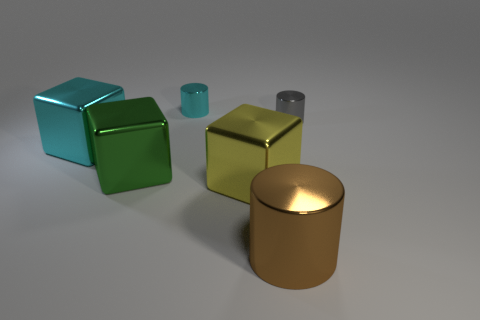Does the brown cylinder have the same size as the cube that is left of the green cube?
Offer a terse response. Yes. There is a cyan object that is in front of the cyan object behind the tiny cylinder that is right of the big brown metallic cylinder; how big is it?
Your answer should be very brief. Large. What size is the green object that is right of the large cyan thing?
Make the answer very short. Large. The gray object that is the same material as the big brown object is what shape?
Your answer should be compact. Cylinder. How many other things are made of the same material as the green thing?
Your response must be concise. 5. What number of things are either small things behind the gray cylinder or tiny cyan cylinders behind the cyan metal block?
Your answer should be compact. 1. There is a tiny thing that is on the right side of the large brown metal cylinder; is its shape the same as the large metallic thing in front of the yellow metallic object?
Keep it short and to the point. Yes. The cyan thing that is the same size as the brown object is what shape?
Your response must be concise. Cube. What number of metal objects are tiny gray things or large blocks?
Provide a short and direct response. 4. Are the block that is on the right side of the tiny cyan shiny cylinder and the cyan object that is to the right of the big cyan metal block made of the same material?
Keep it short and to the point. Yes. 